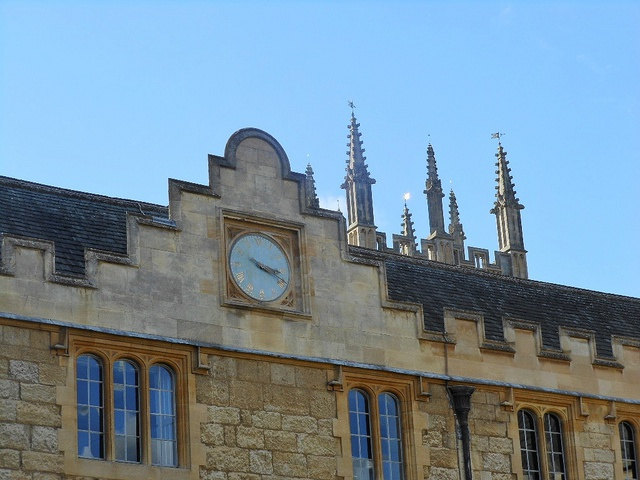Describe the objects in this image and their specific colors. I can see a clock in lightblue, gray, and darkgray tones in this image. 